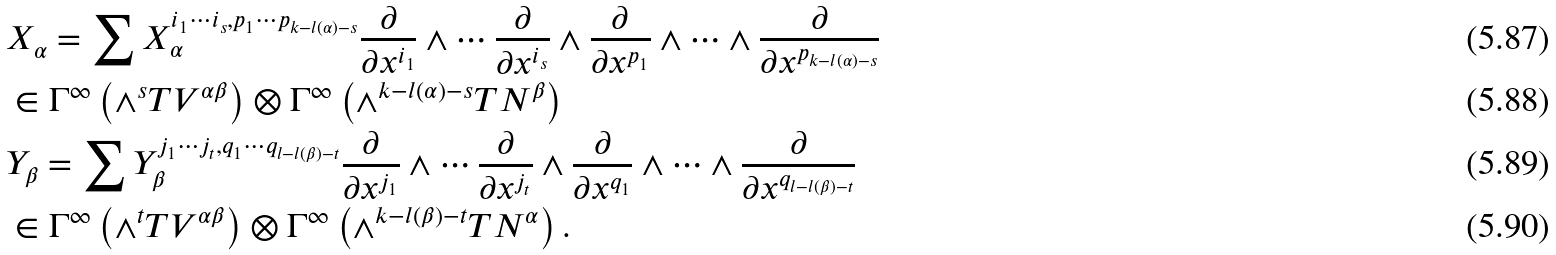Convert formula to latex. <formula><loc_0><loc_0><loc_500><loc_500>& X _ { \alpha } = \sum X _ { \alpha } ^ { i _ { 1 } \cdots i _ { s } , p _ { 1 } \cdots p _ { k - l ( \alpha ) - s } } \frac { \partial } { \partial x ^ { i _ { 1 } } } \wedge \cdots \frac { \partial } { \partial x ^ { i _ { s } } } \wedge \frac { \partial } { \partial x ^ { p _ { 1 } } } \wedge \cdots \wedge \frac { \partial } { \partial x ^ { p _ { k - l ( \alpha ) - s } } } \\ & \in \Gamma ^ { \infty } \left ( \wedge ^ { s } T V ^ { \alpha \beta } \right ) \otimes \Gamma ^ { \infty } \left ( \wedge ^ { k - l ( \alpha ) - s } T N ^ { \beta } \right ) \\ & Y _ { \beta } = \sum Y _ { \beta } ^ { j _ { 1 } \cdots j _ { t } , q _ { 1 } \cdots q _ { l - l ( \beta ) - t } } \frac { \partial } { \partial x ^ { j _ { 1 } } } \wedge \cdots \frac { \partial } { \partial x ^ { j _ { t } } } \wedge \frac { \partial } { \partial x ^ { q _ { 1 } } } \wedge \cdots \wedge \frac { \partial } { \partial x ^ { q _ { l - l ( \beta ) - t } } } \\ & \in \Gamma ^ { \infty } \left ( \wedge ^ { t } T V ^ { \alpha \beta } \right ) \otimes \Gamma ^ { \infty } \left ( \wedge ^ { k - l ( \beta ) - t } T N ^ { \alpha } \right ) .</formula> 